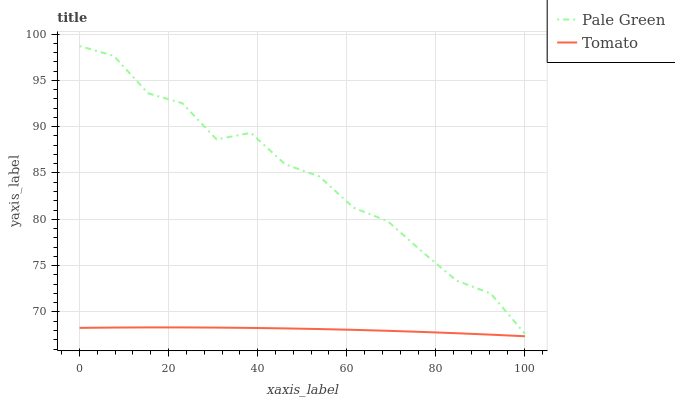Does Tomato have the minimum area under the curve?
Answer yes or no. Yes. Does Pale Green have the maximum area under the curve?
Answer yes or no. Yes. Does Pale Green have the minimum area under the curve?
Answer yes or no. No. Is Tomato the smoothest?
Answer yes or no. Yes. Is Pale Green the roughest?
Answer yes or no. Yes. Is Pale Green the smoothest?
Answer yes or no. No. Does Tomato have the lowest value?
Answer yes or no. Yes. Does Pale Green have the lowest value?
Answer yes or no. No. Does Pale Green have the highest value?
Answer yes or no. Yes. Is Tomato less than Pale Green?
Answer yes or no. Yes. Is Pale Green greater than Tomato?
Answer yes or no. Yes. Does Tomato intersect Pale Green?
Answer yes or no. No. 